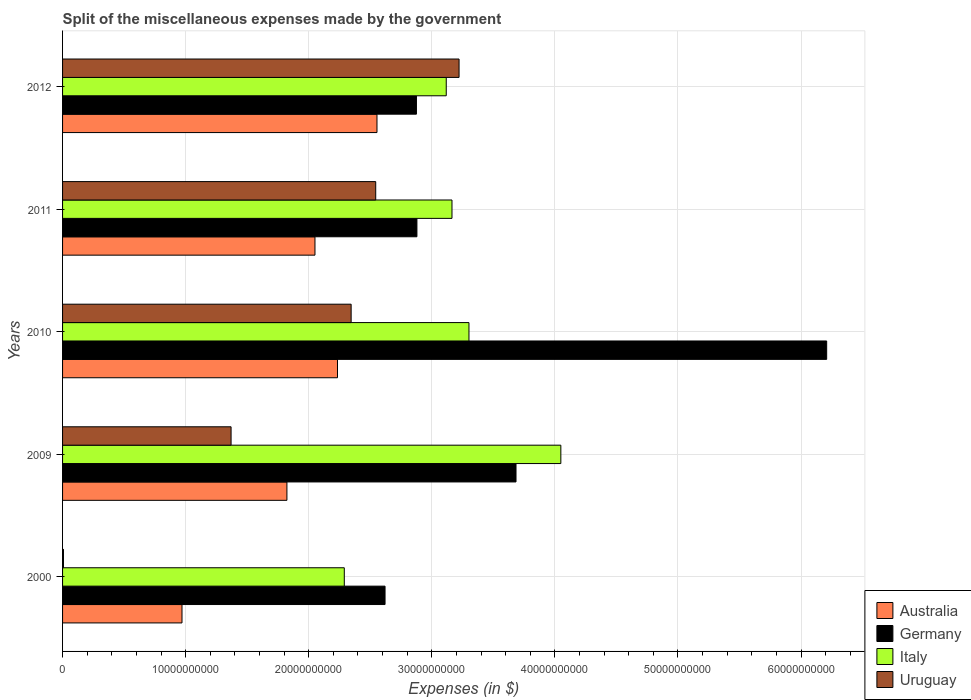How many different coloured bars are there?
Make the answer very short. 4. How many groups of bars are there?
Your answer should be compact. 5. Are the number of bars per tick equal to the number of legend labels?
Give a very brief answer. Yes. How many bars are there on the 1st tick from the top?
Your response must be concise. 4. What is the label of the 5th group of bars from the top?
Ensure brevity in your answer.  2000. In how many cases, is the number of bars for a given year not equal to the number of legend labels?
Give a very brief answer. 0. What is the miscellaneous expenses made by the government in Uruguay in 2012?
Offer a very short reply. 3.22e+1. Across all years, what is the maximum miscellaneous expenses made by the government in Australia?
Give a very brief answer. 2.55e+1. Across all years, what is the minimum miscellaneous expenses made by the government in Germany?
Ensure brevity in your answer.  2.62e+1. In which year was the miscellaneous expenses made by the government in Uruguay maximum?
Give a very brief answer. 2012. What is the total miscellaneous expenses made by the government in Uruguay in the graph?
Offer a terse response. 9.49e+1. What is the difference between the miscellaneous expenses made by the government in Uruguay in 2009 and that in 2010?
Offer a terse response. -9.76e+09. What is the difference between the miscellaneous expenses made by the government in Australia in 2009 and the miscellaneous expenses made by the government in Germany in 2000?
Offer a terse response. -7.97e+09. What is the average miscellaneous expenses made by the government in Uruguay per year?
Ensure brevity in your answer.  1.90e+1. In the year 2010, what is the difference between the miscellaneous expenses made by the government in Italy and miscellaneous expenses made by the government in Germany?
Your answer should be compact. -2.91e+1. What is the ratio of the miscellaneous expenses made by the government in Australia in 2009 to that in 2011?
Your answer should be compact. 0.89. Is the miscellaneous expenses made by the government in Australia in 2000 less than that in 2009?
Your answer should be very brief. Yes. What is the difference between the highest and the second highest miscellaneous expenses made by the government in Australia?
Provide a succinct answer. 3.21e+09. What is the difference between the highest and the lowest miscellaneous expenses made by the government in Uruguay?
Give a very brief answer. 3.21e+1. What does the 4th bar from the top in 2009 represents?
Your response must be concise. Australia. What does the 2nd bar from the bottom in 2011 represents?
Keep it short and to the point. Germany. How many bars are there?
Your response must be concise. 20. Are all the bars in the graph horizontal?
Your answer should be compact. Yes. Are the values on the major ticks of X-axis written in scientific E-notation?
Offer a very short reply. No. Does the graph contain any zero values?
Your answer should be compact. No. How many legend labels are there?
Give a very brief answer. 4. How are the legend labels stacked?
Offer a terse response. Vertical. What is the title of the graph?
Ensure brevity in your answer.  Split of the miscellaneous expenses made by the government. What is the label or title of the X-axis?
Make the answer very short. Expenses (in $). What is the Expenses (in $) of Australia in 2000?
Make the answer very short. 9.70e+09. What is the Expenses (in $) of Germany in 2000?
Your answer should be compact. 2.62e+1. What is the Expenses (in $) of Italy in 2000?
Ensure brevity in your answer.  2.29e+1. What is the Expenses (in $) in Uruguay in 2000?
Ensure brevity in your answer.  7.50e+07. What is the Expenses (in $) in Australia in 2009?
Give a very brief answer. 1.82e+1. What is the Expenses (in $) in Germany in 2009?
Ensure brevity in your answer.  3.68e+1. What is the Expenses (in $) in Italy in 2009?
Give a very brief answer. 4.05e+1. What is the Expenses (in $) of Uruguay in 2009?
Offer a very short reply. 1.37e+1. What is the Expenses (in $) in Australia in 2010?
Your answer should be very brief. 2.23e+1. What is the Expenses (in $) in Germany in 2010?
Keep it short and to the point. 6.21e+1. What is the Expenses (in $) of Italy in 2010?
Offer a terse response. 3.30e+1. What is the Expenses (in $) of Uruguay in 2010?
Provide a short and direct response. 2.34e+1. What is the Expenses (in $) in Australia in 2011?
Make the answer very short. 2.05e+1. What is the Expenses (in $) of Germany in 2011?
Your answer should be compact. 2.88e+1. What is the Expenses (in $) in Italy in 2011?
Keep it short and to the point. 3.16e+1. What is the Expenses (in $) of Uruguay in 2011?
Make the answer very short. 2.54e+1. What is the Expenses (in $) in Australia in 2012?
Keep it short and to the point. 2.55e+1. What is the Expenses (in $) of Germany in 2012?
Offer a terse response. 2.88e+1. What is the Expenses (in $) of Italy in 2012?
Keep it short and to the point. 3.12e+1. What is the Expenses (in $) in Uruguay in 2012?
Offer a very short reply. 3.22e+1. Across all years, what is the maximum Expenses (in $) of Australia?
Offer a very short reply. 2.55e+1. Across all years, what is the maximum Expenses (in $) of Germany?
Provide a short and direct response. 6.21e+1. Across all years, what is the maximum Expenses (in $) of Italy?
Provide a short and direct response. 4.05e+1. Across all years, what is the maximum Expenses (in $) in Uruguay?
Your answer should be compact. 3.22e+1. Across all years, what is the minimum Expenses (in $) of Australia?
Your answer should be compact. 9.70e+09. Across all years, what is the minimum Expenses (in $) of Germany?
Your answer should be very brief. 2.62e+1. Across all years, what is the minimum Expenses (in $) in Italy?
Keep it short and to the point. 2.29e+1. Across all years, what is the minimum Expenses (in $) in Uruguay?
Provide a short and direct response. 7.50e+07. What is the total Expenses (in $) of Australia in the graph?
Offer a very short reply. 9.63e+1. What is the total Expenses (in $) of Germany in the graph?
Offer a terse response. 1.83e+11. What is the total Expenses (in $) of Italy in the graph?
Ensure brevity in your answer.  1.59e+11. What is the total Expenses (in $) of Uruguay in the graph?
Ensure brevity in your answer.  9.49e+1. What is the difference between the Expenses (in $) of Australia in 2000 and that in 2009?
Provide a succinct answer. -8.52e+09. What is the difference between the Expenses (in $) in Germany in 2000 and that in 2009?
Your answer should be compact. -1.06e+1. What is the difference between the Expenses (in $) of Italy in 2000 and that in 2009?
Provide a short and direct response. -1.76e+1. What is the difference between the Expenses (in $) in Uruguay in 2000 and that in 2009?
Your response must be concise. -1.36e+1. What is the difference between the Expenses (in $) in Australia in 2000 and that in 2010?
Make the answer very short. -1.26e+1. What is the difference between the Expenses (in $) in Germany in 2000 and that in 2010?
Offer a very short reply. -3.59e+1. What is the difference between the Expenses (in $) of Italy in 2000 and that in 2010?
Provide a succinct answer. -1.01e+1. What is the difference between the Expenses (in $) in Uruguay in 2000 and that in 2010?
Your response must be concise. -2.34e+1. What is the difference between the Expenses (in $) in Australia in 2000 and that in 2011?
Offer a very short reply. -1.08e+1. What is the difference between the Expenses (in $) in Germany in 2000 and that in 2011?
Your answer should be very brief. -2.59e+09. What is the difference between the Expenses (in $) in Italy in 2000 and that in 2011?
Your answer should be compact. -8.75e+09. What is the difference between the Expenses (in $) of Uruguay in 2000 and that in 2011?
Your answer should be compact. -2.54e+1. What is the difference between the Expenses (in $) in Australia in 2000 and that in 2012?
Provide a succinct answer. -1.58e+1. What is the difference between the Expenses (in $) in Germany in 2000 and that in 2012?
Make the answer very short. -2.55e+09. What is the difference between the Expenses (in $) of Italy in 2000 and that in 2012?
Make the answer very short. -8.28e+09. What is the difference between the Expenses (in $) of Uruguay in 2000 and that in 2012?
Your answer should be compact. -3.21e+1. What is the difference between the Expenses (in $) of Australia in 2009 and that in 2010?
Provide a short and direct response. -4.11e+09. What is the difference between the Expenses (in $) in Germany in 2009 and that in 2010?
Provide a succinct answer. -2.52e+1. What is the difference between the Expenses (in $) in Italy in 2009 and that in 2010?
Give a very brief answer. 7.46e+09. What is the difference between the Expenses (in $) of Uruguay in 2009 and that in 2010?
Give a very brief answer. -9.76e+09. What is the difference between the Expenses (in $) in Australia in 2009 and that in 2011?
Give a very brief answer. -2.28e+09. What is the difference between the Expenses (in $) in Germany in 2009 and that in 2011?
Give a very brief answer. 8.05e+09. What is the difference between the Expenses (in $) in Italy in 2009 and that in 2011?
Your answer should be compact. 8.84e+09. What is the difference between the Expenses (in $) in Uruguay in 2009 and that in 2011?
Offer a terse response. -1.18e+1. What is the difference between the Expenses (in $) of Australia in 2009 and that in 2012?
Your answer should be very brief. -7.32e+09. What is the difference between the Expenses (in $) in Germany in 2009 and that in 2012?
Your answer should be compact. 8.09e+09. What is the difference between the Expenses (in $) in Italy in 2009 and that in 2012?
Your answer should be very brief. 9.31e+09. What is the difference between the Expenses (in $) in Uruguay in 2009 and that in 2012?
Give a very brief answer. -1.85e+1. What is the difference between the Expenses (in $) in Australia in 2010 and that in 2011?
Keep it short and to the point. 1.83e+09. What is the difference between the Expenses (in $) in Germany in 2010 and that in 2011?
Keep it short and to the point. 3.33e+1. What is the difference between the Expenses (in $) in Italy in 2010 and that in 2011?
Provide a succinct answer. 1.38e+09. What is the difference between the Expenses (in $) of Uruguay in 2010 and that in 2011?
Your answer should be very brief. -2.00e+09. What is the difference between the Expenses (in $) in Australia in 2010 and that in 2012?
Your response must be concise. -3.21e+09. What is the difference between the Expenses (in $) of Germany in 2010 and that in 2012?
Provide a short and direct response. 3.33e+1. What is the difference between the Expenses (in $) in Italy in 2010 and that in 2012?
Your answer should be very brief. 1.85e+09. What is the difference between the Expenses (in $) in Uruguay in 2010 and that in 2012?
Make the answer very short. -8.77e+09. What is the difference between the Expenses (in $) of Australia in 2011 and that in 2012?
Offer a terse response. -5.04e+09. What is the difference between the Expenses (in $) of Germany in 2011 and that in 2012?
Make the answer very short. 4.00e+07. What is the difference between the Expenses (in $) of Italy in 2011 and that in 2012?
Provide a short and direct response. 4.66e+08. What is the difference between the Expenses (in $) of Uruguay in 2011 and that in 2012?
Offer a very short reply. -6.77e+09. What is the difference between the Expenses (in $) in Australia in 2000 and the Expenses (in $) in Germany in 2009?
Give a very brief answer. -2.71e+1. What is the difference between the Expenses (in $) of Australia in 2000 and the Expenses (in $) of Italy in 2009?
Offer a terse response. -3.08e+1. What is the difference between the Expenses (in $) in Australia in 2000 and the Expenses (in $) in Uruguay in 2009?
Your answer should be compact. -3.99e+09. What is the difference between the Expenses (in $) of Germany in 2000 and the Expenses (in $) of Italy in 2009?
Offer a very short reply. -1.43e+1. What is the difference between the Expenses (in $) of Germany in 2000 and the Expenses (in $) of Uruguay in 2009?
Your answer should be compact. 1.25e+1. What is the difference between the Expenses (in $) in Italy in 2000 and the Expenses (in $) in Uruguay in 2009?
Your response must be concise. 9.20e+09. What is the difference between the Expenses (in $) of Australia in 2000 and the Expenses (in $) of Germany in 2010?
Provide a succinct answer. -5.24e+1. What is the difference between the Expenses (in $) in Australia in 2000 and the Expenses (in $) in Italy in 2010?
Ensure brevity in your answer.  -2.33e+1. What is the difference between the Expenses (in $) of Australia in 2000 and the Expenses (in $) of Uruguay in 2010?
Offer a terse response. -1.37e+1. What is the difference between the Expenses (in $) in Germany in 2000 and the Expenses (in $) in Italy in 2010?
Make the answer very short. -6.82e+09. What is the difference between the Expenses (in $) in Germany in 2000 and the Expenses (in $) in Uruguay in 2010?
Provide a succinct answer. 2.75e+09. What is the difference between the Expenses (in $) of Italy in 2000 and the Expenses (in $) of Uruguay in 2010?
Ensure brevity in your answer.  -5.57e+08. What is the difference between the Expenses (in $) in Australia in 2000 and the Expenses (in $) in Germany in 2011?
Keep it short and to the point. -1.91e+1. What is the difference between the Expenses (in $) of Australia in 2000 and the Expenses (in $) of Italy in 2011?
Provide a succinct answer. -2.19e+1. What is the difference between the Expenses (in $) in Australia in 2000 and the Expenses (in $) in Uruguay in 2011?
Give a very brief answer. -1.57e+1. What is the difference between the Expenses (in $) of Germany in 2000 and the Expenses (in $) of Italy in 2011?
Your answer should be very brief. -5.44e+09. What is the difference between the Expenses (in $) in Germany in 2000 and the Expenses (in $) in Uruguay in 2011?
Keep it short and to the point. 7.58e+08. What is the difference between the Expenses (in $) in Italy in 2000 and the Expenses (in $) in Uruguay in 2011?
Ensure brevity in your answer.  -2.55e+09. What is the difference between the Expenses (in $) of Australia in 2000 and the Expenses (in $) of Germany in 2012?
Offer a terse response. -1.90e+1. What is the difference between the Expenses (in $) of Australia in 2000 and the Expenses (in $) of Italy in 2012?
Offer a terse response. -2.15e+1. What is the difference between the Expenses (in $) of Australia in 2000 and the Expenses (in $) of Uruguay in 2012?
Provide a succinct answer. -2.25e+1. What is the difference between the Expenses (in $) of Germany in 2000 and the Expenses (in $) of Italy in 2012?
Your answer should be compact. -4.97e+09. What is the difference between the Expenses (in $) of Germany in 2000 and the Expenses (in $) of Uruguay in 2012?
Make the answer very short. -6.01e+09. What is the difference between the Expenses (in $) of Italy in 2000 and the Expenses (in $) of Uruguay in 2012?
Your response must be concise. -9.32e+09. What is the difference between the Expenses (in $) in Australia in 2009 and the Expenses (in $) in Germany in 2010?
Give a very brief answer. -4.39e+1. What is the difference between the Expenses (in $) of Australia in 2009 and the Expenses (in $) of Italy in 2010?
Keep it short and to the point. -1.48e+1. What is the difference between the Expenses (in $) of Australia in 2009 and the Expenses (in $) of Uruguay in 2010?
Offer a very short reply. -5.22e+09. What is the difference between the Expenses (in $) in Germany in 2009 and the Expenses (in $) in Italy in 2010?
Make the answer very short. 3.82e+09. What is the difference between the Expenses (in $) in Germany in 2009 and the Expenses (in $) in Uruguay in 2010?
Provide a succinct answer. 1.34e+1. What is the difference between the Expenses (in $) in Italy in 2009 and the Expenses (in $) in Uruguay in 2010?
Your answer should be compact. 1.70e+1. What is the difference between the Expenses (in $) in Australia in 2009 and the Expenses (in $) in Germany in 2011?
Make the answer very short. -1.06e+1. What is the difference between the Expenses (in $) in Australia in 2009 and the Expenses (in $) in Italy in 2011?
Your response must be concise. -1.34e+1. What is the difference between the Expenses (in $) of Australia in 2009 and the Expenses (in $) of Uruguay in 2011?
Keep it short and to the point. -7.21e+09. What is the difference between the Expenses (in $) of Germany in 2009 and the Expenses (in $) of Italy in 2011?
Make the answer very short. 5.20e+09. What is the difference between the Expenses (in $) of Germany in 2009 and the Expenses (in $) of Uruguay in 2011?
Your answer should be compact. 1.14e+1. What is the difference between the Expenses (in $) of Italy in 2009 and the Expenses (in $) of Uruguay in 2011?
Offer a very short reply. 1.50e+1. What is the difference between the Expenses (in $) of Australia in 2009 and the Expenses (in $) of Germany in 2012?
Provide a short and direct response. -1.05e+1. What is the difference between the Expenses (in $) in Australia in 2009 and the Expenses (in $) in Italy in 2012?
Your answer should be very brief. -1.29e+1. What is the difference between the Expenses (in $) in Australia in 2009 and the Expenses (in $) in Uruguay in 2012?
Offer a very short reply. -1.40e+1. What is the difference between the Expenses (in $) in Germany in 2009 and the Expenses (in $) in Italy in 2012?
Your response must be concise. 5.67e+09. What is the difference between the Expenses (in $) in Germany in 2009 and the Expenses (in $) in Uruguay in 2012?
Offer a terse response. 4.63e+09. What is the difference between the Expenses (in $) in Italy in 2009 and the Expenses (in $) in Uruguay in 2012?
Keep it short and to the point. 8.27e+09. What is the difference between the Expenses (in $) in Australia in 2010 and the Expenses (in $) in Germany in 2011?
Your answer should be very brief. -6.45e+09. What is the difference between the Expenses (in $) of Australia in 2010 and the Expenses (in $) of Italy in 2011?
Make the answer very short. -9.30e+09. What is the difference between the Expenses (in $) in Australia in 2010 and the Expenses (in $) in Uruguay in 2011?
Give a very brief answer. -3.10e+09. What is the difference between the Expenses (in $) in Germany in 2010 and the Expenses (in $) in Italy in 2011?
Give a very brief answer. 3.04e+1. What is the difference between the Expenses (in $) in Germany in 2010 and the Expenses (in $) in Uruguay in 2011?
Offer a terse response. 3.66e+1. What is the difference between the Expenses (in $) in Italy in 2010 and the Expenses (in $) in Uruguay in 2011?
Your answer should be compact. 7.58e+09. What is the difference between the Expenses (in $) of Australia in 2010 and the Expenses (in $) of Germany in 2012?
Keep it short and to the point. -6.41e+09. What is the difference between the Expenses (in $) in Australia in 2010 and the Expenses (in $) in Italy in 2012?
Ensure brevity in your answer.  -8.84e+09. What is the difference between the Expenses (in $) in Australia in 2010 and the Expenses (in $) in Uruguay in 2012?
Your answer should be compact. -9.88e+09. What is the difference between the Expenses (in $) of Germany in 2010 and the Expenses (in $) of Italy in 2012?
Offer a very short reply. 3.09e+1. What is the difference between the Expenses (in $) of Germany in 2010 and the Expenses (in $) of Uruguay in 2012?
Offer a terse response. 2.99e+1. What is the difference between the Expenses (in $) in Italy in 2010 and the Expenses (in $) in Uruguay in 2012?
Ensure brevity in your answer.  8.04e+08. What is the difference between the Expenses (in $) of Australia in 2011 and the Expenses (in $) of Germany in 2012?
Give a very brief answer. -8.24e+09. What is the difference between the Expenses (in $) in Australia in 2011 and the Expenses (in $) in Italy in 2012?
Provide a short and direct response. -1.07e+1. What is the difference between the Expenses (in $) in Australia in 2011 and the Expenses (in $) in Uruguay in 2012?
Offer a very short reply. -1.17e+1. What is the difference between the Expenses (in $) of Germany in 2011 and the Expenses (in $) of Italy in 2012?
Your answer should be compact. -2.38e+09. What is the difference between the Expenses (in $) in Germany in 2011 and the Expenses (in $) in Uruguay in 2012?
Your answer should be very brief. -3.42e+09. What is the difference between the Expenses (in $) in Italy in 2011 and the Expenses (in $) in Uruguay in 2012?
Offer a very short reply. -5.76e+08. What is the average Expenses (in $) in Australia per year?
Your answer should be compact. 1.93e+1. What is the average Expenses (in $) in Germany per year?
Give a very brief answer. 3.65e+1. What is the average Expenses (in $) of Italy per year?
Keep it short and to the point. 3.18e+1. What is the average Expenses (in $) of Uruguay per year?
Your response must be concise. 1.90e+1. In the year 2000, what is the difference between the Expenses (in $) of Australia and Expenses (in $) of Germany?
Ensure brevity in your answer.  -1.65e+1. In the year 2000, what is the difference between the Expenses (in $) in Australia and Expenses (in $) in Italy?
Offer a terse response. -1.32e+1. In the year 2000, what is the difference between the Expenses (in $) of Australia and Expenses (in $) of Uruguay?
Offer a very short reply. 9.63e+09. In the year 2000, what is the difference between the Expenses (in $) in Germany and Expenses (in $) in Italy?
Make the answer very short. 3.31e+09. In the year 2000, what is the difference between the Expenses (in $) in Germany and Expenses (in $) in Uruguay?
Give a very brief answer. 2.61e+1. In the year 2000, what is the difference between the Expenses (in $) of Italy and Expenses (in $) of Uruguay?
Offer a very short reply. 2.28e+1. In the year 2009, what is the difference between the Expenses (in $) in Australia and Expenses (in $) in Germany?
Give a very brief answer. -1.86e+1. In the year 2009, what is the difference between the Expenses (in $) in Australia and Expenses (in $) in Italy?
Ensure brevity in your answer.  -2.23e+1. In the year 2009, what is the difference between the Expenses (in $) in Australia and Expenses (in $) in Uruguay?
Provide a short and direct response. 4.54e+09. In the year 2009, what is the difference between the Expenses (in $) of Germany and Expenses (in $) of Italy?
Keep it short and to the point. -3.64e+09. In the year 2009, what is the difference between the Expenses (in $) of Germany and Expenses (in $) of Uruguay?
Your response must be concise. 2.31e+1. In the year 2009, what is the difference between the Expenses (in $) of Italy and Expenses (in $) of Uruguay?
Offer a terse response. 2.68e+1. In the year 2010, what is the difference between the Expenses (in $) in Australia and Expenses (in $) in Germany?
Provide a short and direct response. -3.97e+1. In the year 2010, what is the difference between the Expenses (in $) in Australia and Expenses (in $) in Italy?
Offer a terse response. -1.07e+1. In the year 2010, what is the difference between the Expenses (in $) of Australia and Expenses (in $) of Uruguay?
Keep it short and to the point. -1.11e+09. In the year 2010, what is the difference between the Expenses (in $) of Germany and Expenses (in $) of Italy?
Your response must be concise. 2.91e+1. In the year 2010, what is the difference between the Expenses (in $) of Germany and Expenses (in $) of Uruguay?
Provide a short and direct response. 3.86e+1. In the year 2010, what is the difference between the Expenses (in $) in Italy and Expenses (in $) in Uruguay?
Offer a very short reply. 9.57e+09. In the year 2011, what is the difference between the Expenses (in $) of Australia and Expenses (in $) of Germany?
Give a very brief answer. -8.28e+09. In the year 2011, what is the difference between the Expenses (in $) in Australia and Expenses (in $) in Italy?
Provide a short and direct response. -1.11e+1. In the year 2011, what is the difference between the Expenses (in $) in Australia and Expenses (in $) in Uruguay?
Keep it short and to the point. -4.94e+09. In the year 2011, what is the difference between the Expenses (in $) in Germany and Expenses (in $) in Italy?
Provide a succinct answer. -2.85e+09. In the year 2011, what is the difference between the Expenses (in $) in Germany and Expenses (in $) in Uruguay?
Give a very brief answer. 3.35e+09. In the year 2011, what is the difference between the Expenses (in $) in Italy and Expenses (in $) in Uruguay?
Keep it short and to the point. 6.20e+09. In the year 2012, what is the difference between the Expenses (in $) of Australia and Expenses (in $) of Germany?
Provide a succinct answer. -3.20e+09. In the year 2012, what is the difference between the Expenses (in $) of Australia and Expenses (in $) of Italy?
Offer a very short reply. -5.63e+09. In the year 2012, what is the difference between the Expenses (in $) of Australia and Expenses (in $) of Uruguay?
Make the answer very short. -6.67e+09. In the year 2012, what is the difference between the Expenses (in $) of Germany and Expenses (in $) of Italy?
Offer a terse response. -2.42e+09. In the year 2012, what is the difference between the Expenses (in $) in Germany and Expenses (in $) in Uruguay?
Provide a short and direct response. -3.46e+09. In the year 2012, what is the difference between the Expenses (in $) of Italy and Expenses (in $) of Uruguay?
Your answer should be very brief. -1.04e+09. What is the ratio of the Expenses (in $) of Australia in 2000 to that in 2009?
Offer a very short reply. 0.53. What is the ratio of the Expenses (in $) in Germany in 2000 to that in 2009?
Keep it short and to the point. 0.71. What is the ratio of the Expenses (in $) of Italy in 2000 to that in 2009?
Your response must be concise. 0.57. What is the ratio of the Expenses (in $) in Uruguay in 2000 to that in 2009?
Provide a succinct answer. 0.01. What is the ratio of the Expenses (in $) of Australia in 2000 to that in 2010?
Keep it short and to the point. 0.43. What is the ratio of the Expenses (in $) in Germany in 2000 to that in 2010?
Keep it short and to the point. 0.42. What is the ratio of the Expenses (in $) of Italy in 2000 to that in 2010?
Offer a very short reply. 0.69. What is the ratio of the Expenses (in $) of Uruguay in 2000 to that in 2010?
Your answer should be very brief. 0. What is the ratio of the Expenses (in $) of Australia in 2000 to that in 2011?
Make the answer very short. 0.47. What is the ratio of the Expenses (in $) of Germany in 2000 to that in 2011?
Your answer should be very brief. 0.91. What is the ratio of the Expenses (in $) in Italy in 2000 to that in 2011?
Provide a short and direct response. 0.72. What is the ratio of the Expenses (in $) of Uruguay in 2000 to that in 2011?
Offer a terse response. 0. What is the ratio of the Expenses (in $) in Australia in 2000 to that in 2012?
Your response must be concise. 0.38. What is the ratio of the Expenses (in $) of Germany in 2000 to that in 2012?
Offer a terse response. 0.91. What is the ratio of the Expenses (in $) of Italy in 2000 to that in 2012?
Give a very brief answer. 0.73. What is the ratio of the Expenses (in $) in Uruguay in 2000 to that in 2012?
Your answer should be very brief. 0. What is the ratio of the Expenses (in $) of Australia in 2009 to that in 2010?
Provide a succinct answer. 0.82. What is the ratio of the Expenses (in $) in Germany in 2009 to that in 2010?
Keep it short and to the point. 0.59. What is the ratio of the Expenses (in $) in Italy in 2009 to that in 2010?
Give a very brief answer. 1.23. What is the ratio of the Expenses (in $) in Uruguay in 2009 to that in 2010?
Your answer should be very brief. 0.58. What is the ratio of the Expenses (in $) of Australia in 2009 to that in 2011?
Give a very brief answer. 0.89. What is the ratio of the Expenses (in $) in Germany in 2009 to that in 2011?
Your answer should be compact. 1.28. What is the ratio of the Expenses (in $) of Italy in 2009 to that in 2011?
Provide a short and direct response. 1.28. What is the ratio of the Expenses (in $) of Uruguay in 2009 to that in 2011?
Make the answer very short. 0.54. What is the ratio of the Expenses (in $) in Australia in 2009 to that in 2012?
Keep it short and to the point. 0.71. What is the ratio of the Expenses (in $) of Germany in 2009 to that in 2012?
Your response must be concise. 1.28. What is the ratio of the Expenses (in $) in Italy in 2009 to that in 2012?
Offer a terse response. 1.3. What is the ratio of the Expenses (in $) in Uruguay in 2009 to that in 2012?
Make the answer very short. 0.42. What is the ratio of the Expenses (in $) of Australia in 2010 to that in 2011?
Ensure brevity in your answer.  1.09. What is the ratio of the Expenses (in $) of Germany in 2010 to that in 2011?
Ensure brevity in your answer.  2.16. What is the ratio of the Expenses (in $) in Italy in 2010 to that in 2011?
Provide a short and direct response. 1.04. What is the ratio of the Expenses (in $) in Uruguay in 2010 to that in 2011?
Give a very brief answer. 0.92. What is the ratio of the Expenses (in $) in Australia in 2010 to that in 2012?
Your answer should be very brief. 0.87. What is the ratio of the Expenses (in $) in Germany in 2010 to that in 2012?
Keep it short and to the point. 2.16. What is the ratio of the Expenses (in $) in Italy in 2010 to that in 2012?
Give a very brief answer. 1.06. What is the ratio of the Expenses (in $) of Uruguay in 2010 to that in 2012?
Provide a short and direct response. 0.73. What is the ratio of the Expenses (in $) in Australia in 2011 to that in 2012?
Provide a succinct answer. 0.8. What is the ratio of the Expenses (in $) of Italy in 2011 to that in 2012?
Offer a very short reply. 1.01. What is the ratio of the Expenses (in $) in Uruguay in 2011 to that in 2012?
Give a very brief answer. 0.79. What is the difference between the highest and the second highest Expenses (in $) in Australia?
Offer a terse response. 3.21e+09. What is the difference between the highest and the second highest Expenses (in $) of Germany?
Ensure brevity in your answer.  2.52e+1. What is the difference between the highest and the second highest Expenses (in $) of Italy?
Your response must be concise. 7.46e+09. What is the difference between the highest and the second highest Expenses (in $) in Uruguay?
Offer a terse response. 6.77e+09. What is the difference between the highest and the lowest Expenses (in $) in Australia?
Your answer should be compact. 1.58e+1. What is the difference between the highest and the lowest Expenses (in $) in Germany?
Offer a terse response. 3.59e+1. What is the difference between the highest and the lowest Expenses (in $) of Italy?
Your answer should be very brief. 1.76e+1. What is the difference between the highest and the lowest Expenses (in $) in Uruguay?
Your answer should be compact. 3.21e+1. 